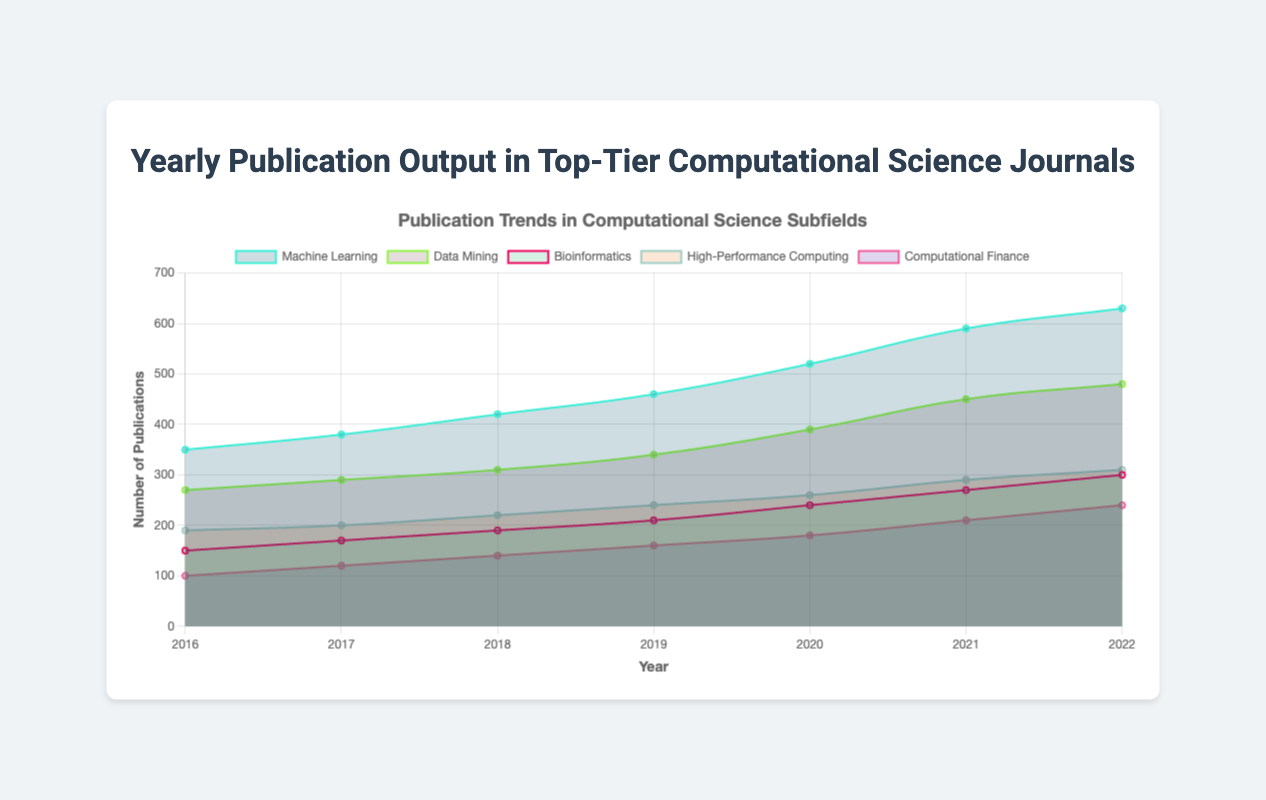What is the title of the chart? The title of the chart is clearly displayed at the top center. It reads, "Yearly Publication Output in Top-Tier Computational Science Journals".
Answer: Yearly Publication Output in Top-Tier Computational Science Journals Which subfield had the highest publication output in 2022? By observing the highest points on the plot for each subfield in 2022, Machine Learning has the highest publication output with 630 publications.
Answer: Machine Learning How many subfields are represented in the chart? By counting the different colored areas (each representing a subfield) in the chart, there are five subfields represented.
Answer: Five What is the trend for publications in High-Performance Computing from 2016 to 2022? The trend for High-Performance Computing shows a steady increase in publications each year, starting from 190 in 2016 to 310 in 2022.
Answer: Steadily increasing Which subfield had a consistent increase in publications every year between 2016 and 2022? Observing the publication data for each subfield across the years, Machine Learning shows a consistent increase in publications every year.
Answer: Machine Learning How do the publication trends in 2020 for Bioinformatics compare to those in Data Mining? In 2020, Bioinformatics had 240 publications, while Data Mining had 390. Comparing both, Data Mining had significantly more publications than Bioinformatics in 2020.
Answer: Data Mining had significantly more What was the total number of publications across all subfields in 2021? Adding up the publications for each subfield in 2021: Machine Learning (590), Data Mining (450), Bioinformatics (270), High-Performance Computing (290), and Computational Finance (210), the total is 590 + 450 + 270 + 290 + 210 = 1810.
Answer: 1810 Was there any year in which two subfields had the same number of publications? Reviewing the data for each subfield year by year, there is no year in which two subfields had the exact same number of publications.
Answer: No Which subfield observed the smallest increase in publications from 2016 to 2017? Calculating the difference in publications from 2016 to 2017 for each subfield: Machine Learning (380-350=30), Data Mining (290-270=20), Bioinformatics (170-150=20), High-Performance Computing (200-190=10), and Computational Finance (120-100=20), High-Performance Computing had the smallest increase.
Answer: High-Performance Computing What was the relative increase in publications for Computational Finance from 2020 to 2022? The publications for Computational Finance increased from 180 in 2020 to 240 in 2022. To find the relative increase: ((240-180)/180) * 100 = 33.33%.
Answer: 33.33% 